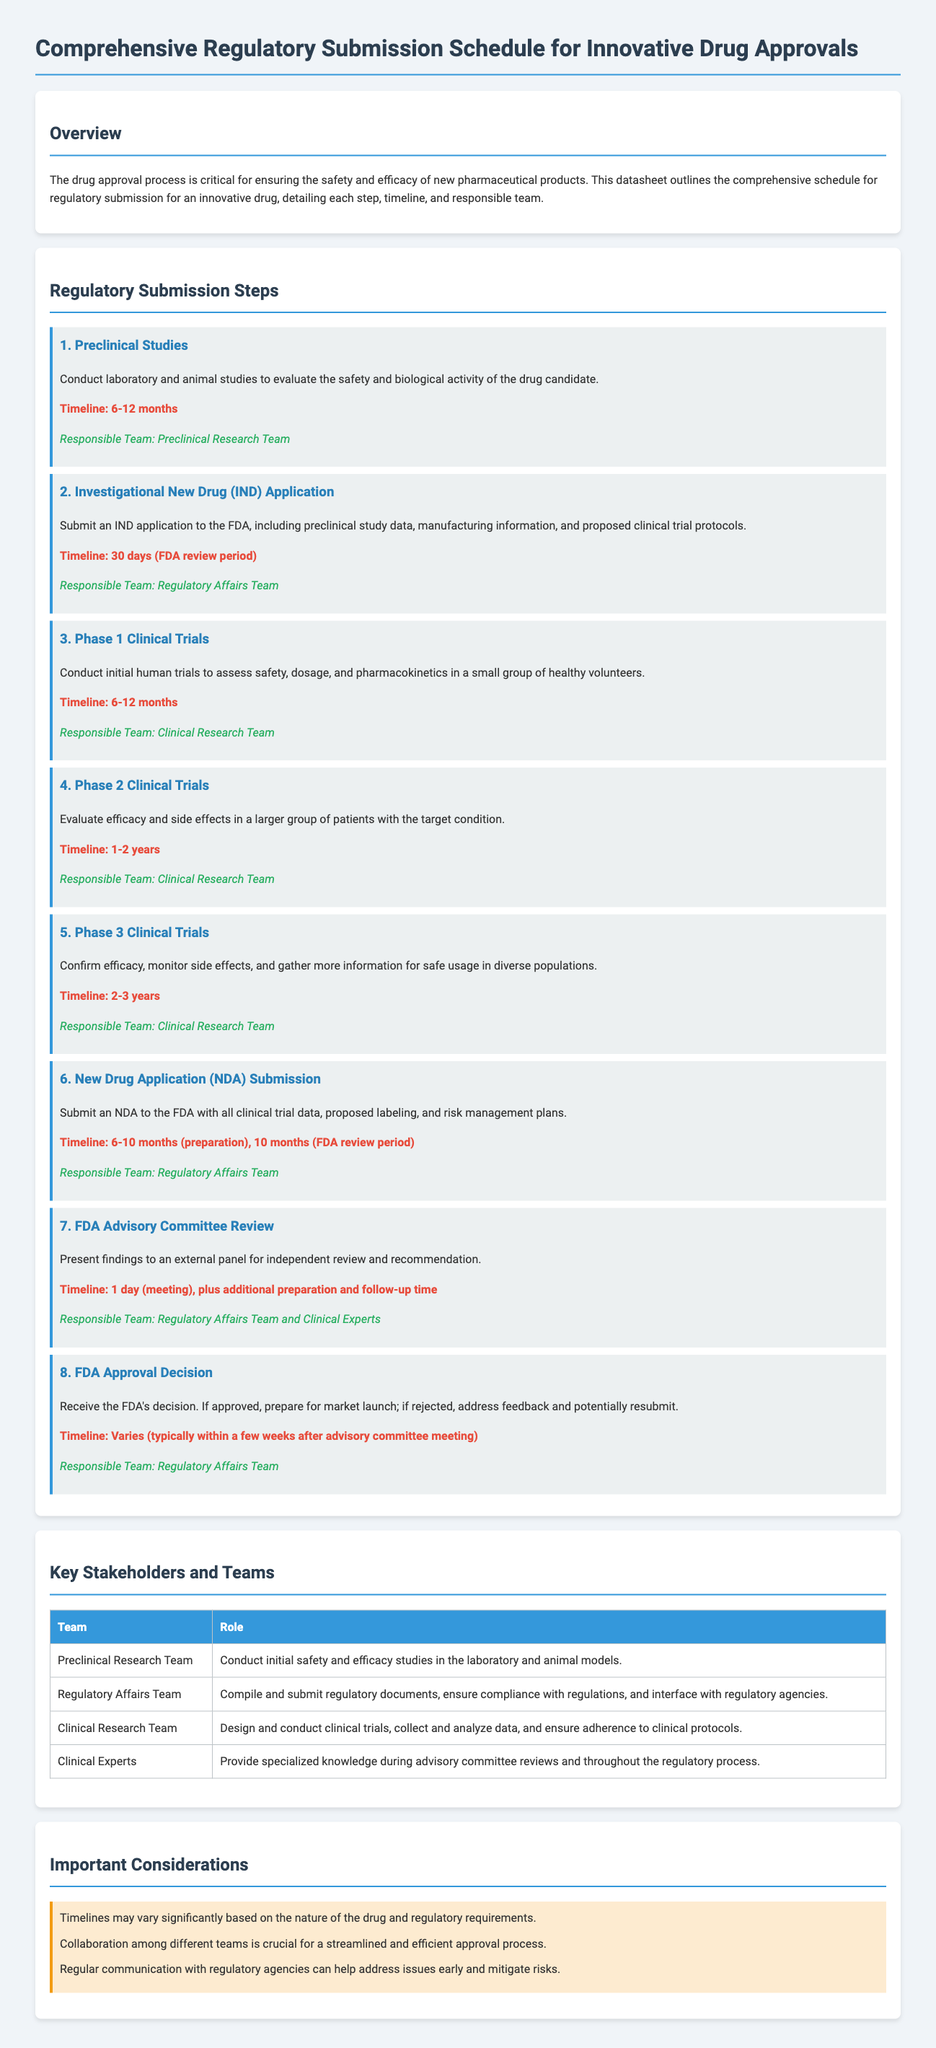What is the first step in the regulatory submission process? The first step is outlined in the section "Regulatory Submission Steps," focusing on preclinical studies.
Answer: Preclinical Studies How long is the timeline for Phase 1 Clinical Trials? The timeline for Phase 1 Clinical Trials is specified in the document, detailing the duration.
Answer: 6-12 months Which team is responsible for the Investigational New Drug Application? The document states the responsible team for the IND application in the description of that step.
Answer: Regulatory Affairs Team What is the timeline for the New Drug Application submission preparation? The document specifies the preparation timeline for the NDA submission, indicating a specific range.
Answer: 6-10 months Who provides specialized knowledge during advisory committee reviews? The document mentions the role of specific experts during the advisory committee review, identifying the appropriate team.
Answer: Clinical Experts What step in the process involves confirming efficacy and monitoring side effects? This aspect relates to the phase indicated in the "Regulatory Submission Steps" section of the document.
Answer: Phase 3 Clinical Trials How many phases are there in the clinical trials mentioned? The clinical trial phases are numbered in the document, allowing for a direct count of the phases discussed.
Answer: 3 phases What is a key consideration highlighted in the important considerations section? The document lists various considerations, providing insight into essential factors in the approval process.
Answer: Timelines may vary significantly based on the nature of the drug and regulatory requirements 